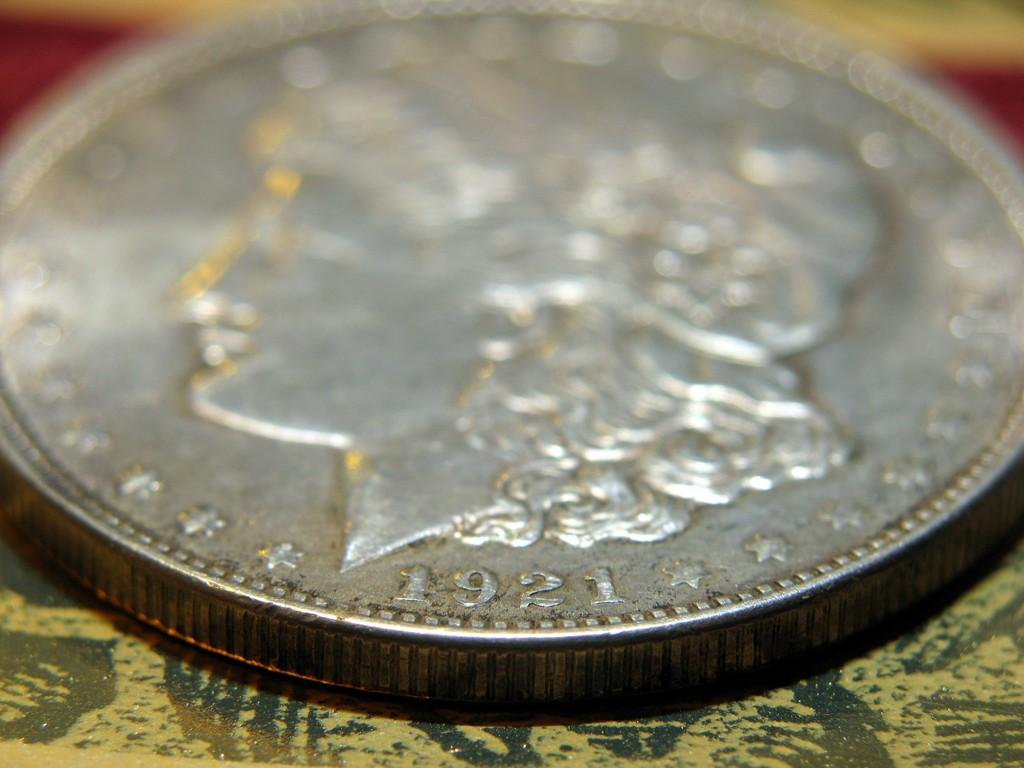<image>
Give a short and clear explanation of the subsequent image. A coin has the year 1921 below the head. 